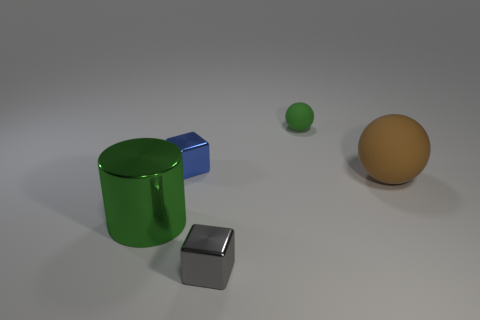What time of day does the lighting in the image suggest? The image has a soft and diffused lighting, which doesn't strongly suggest any particular time of day. It is likely that the scene is artificially lit, as indicated by the lack of shadows and the uniform lighting across the objects. 